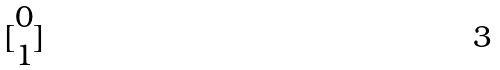<formula> <loc_0><loc_0><loc_500><loc_500>[ \begin{matrix} 0 \\ 1 \end{matrix} ]</formula> 